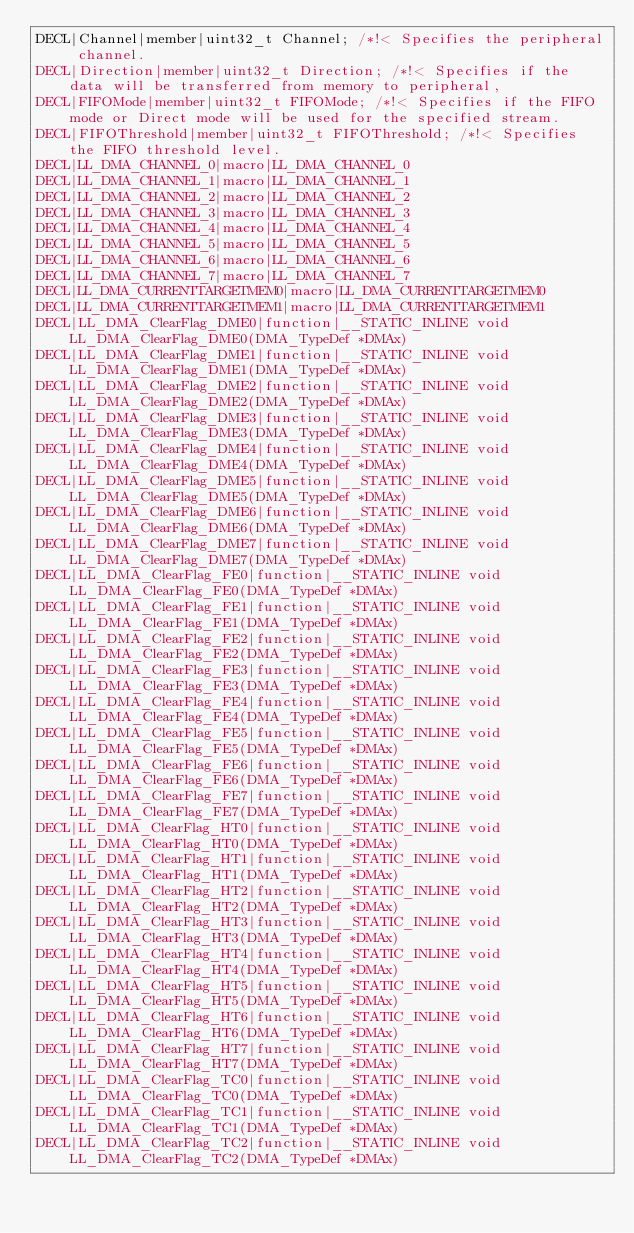<code> <loc_0><loc_0><loc_500><loc_500><_C_>DECL|Channel|member|uint32_t Channel; /*!< Specifies the peripheral channel.
DECL|Direction|member|uint32_t Direction; /*!< Specifies if the data will be transferred from memory to peripheral,
DECL|FIFOMode|member|uint32_t FIFOMode; /*!< Specifies if the FIFO mode or Direct mode will be used for the specified stream.
DECL|FIFOThreshold|member|uint32_t FIFOThreshold; /*!< Specifies the FIFO threshold level.
DECL|LL_DMA_CHANNEL_0|macro|LL_DMA_CHANNEL_0
DECL|LL_DMA_CHANNEL_1|macro|LL_DMA_CHANNEL_1
DECL|LL_DMA_CHANNEL_2|macro|LL_DMA_CHANNEL_2
DECL|LL_DMA_CHANNEL_3|macro|LL_DMA_CHANNEL_3
DECL|LL_DMA_CHANNEL_4|macro|LL_DMA_CHANNEL_4
DECL|LL_DMA_CHANNEL_5|macro|LL_DMA_CHANNEL_5
DECL|LL_DMA_CHANNEL_6|macro|LL_DMA_CHANNEL_6
DECL|LL_DMA_CHANNEL_7|macro|LL_DMA_CHANNEL_7
DECL|LL_DMA_CURRENTTARGETMEM0|macro|LL_DMA_CURRENTTARGETMEM0
DECL|LL_DMA_CURRENTTARGETMEM1|macro|LL_DMA_CURRENTTARGETMEM1
DECL|LL_DMA_ClearFlag_DME0|function|__STATIC_INLINE void LL_DMA_ClearFlag_DME0(DMA_TypeDef *DMAx)
DECL|LL_DMA_ClearFlag_DME1|function|__STATIC_INLINE void LL_DMA_ClearFlag_DME1(DMA_TypeDef *DMAx)
DECL|LL_DMA_ClearFlag_DME2|function|__STATIC_INLINE void LL_DMA_ClearFlag_DME2(DMA_TypeDef *DMAx)
DECL|LL_DMA_ClearFlag_DME3|function|__STATIC_INLINE void LL_DMA_ClearFlag_DME3(DMA_TypeDef *DMAx)
DECL|LL_DMA_ClearFlag_DME4|function|__STATIC_INLINE void LL_DMA_ClearFlag_DME4(DMA_TypeDef *DMAx)
DECL|LL_DMA_ClearFlag_DME5|function|__STATIC_INLINE void LL_DMA_ClearFlag_DME5(DMA_TypeDef *DMAx)
DECL|LL_DMA_ClearFlag_DME6|function|__STATIC_INLINE void LL_DMA_ClearFlag_DME6(DMA_TypeDef *DMAx)
DECL|LL_DMA_ClearFlag_DME7|function|__STATIC_INLINE void LL_DMA_ClearFlag_DME7(DMA_TypeDef *DMAx)
DECL|LL_DMA_ClearFlag_FE0|function|__STATIC_INLINE void LL_DMA_ClearFlag_FE0(DMA_TypeDef *DMAx)
DECL|LL_DMA_ClearFlag_FE1|function|__STATIC_INLINE void LL_DMA_ClearFlag_FE1(DMA_TypeDef *DMAx)
DECL|LL_DMA_ClearFlag_FE2|function|__STATIC_INLINE void LL_DMA_ClearFlag_FE2(DMA_TypeDef *DMAx)
DECL|LL_DMA_ClearFlag_FE3|function|__STATIC_INLINE void LL_DMA_ClearFlag_FE3(DMA_TypeDef *DMAx)
DECL|LL_DMA_ClearFlag_FE4|function|__STATIC_INLINE void LL_DMA_ClearFlag_FE4(DMA_TypeDef *DMAx)
DECL|LL_DMA_ClearFlag_FE5|function|__STATIC_INLINE void LL_DMA_ClearFlag_FE5(DMA_TypeDef *DMAx)
DECL|LL_DMA_ClearFlag_FE6|function|__STATIC_INLINE void LL_DMA_ClearFlag_FE6(DMA_TypeDef *DMAx)
DECL|LL_DMA_ClearFlag_FE7|function|__STATIC_INLINE void LL_DMA_ClearFlag_FE7(DMA_TypeDef *DMAx)
DECL|LL_DMA_ClearFlag_HT0|function|__STATIC_INLINE void LL_DMA_ClearFlag_HT0(DMA_TypeDef *DMAx)
DECL|LL_DMA_ClearFlag_HT1|function|__STATIC_INLINE void LL_DMA_ClearFlag_HT1(DMA_TypeDef *DMAx)
DECL|LL_DMA_ClearFlag_HT2|function|__STATIC_INLINE void LL_DMA_ClearFlag_HT2(DMA_TypeDef *DMAx)
DECL|LL_DMA_ClearFlag_HT3|function|__STATIC_INLINE void LL_DMA_ClearFlag_HT3(DMA_TypeDef *DMAx)
DECL|LL_DMA_ClearFlag_HT4|function|__STATIC_INLINE void LL_DMA_ClearFlag_HT4(DMA_TypeDef *DMAx)
DECL|LL_DMA_ClearFlag_HT5|function|__STATIC_INLINE void LL_DMA_ClearFlag_HT5(DMA_TypeDef *DMAx)
DECL|LL_DMA_ClearFlag_HT6|function|__STATIC_INLINE void LL_DMA_ClearFlag_HT6(DMA_TypeDef *DMAx)
DECL|LL_DMA_ClearFlag_HT7|function|__STATIC_INLINE void LL_DMA_ClearFlag_HT7(DMA_TypeDef *DMAx)
DECL|LL_DMA_ClearFlag_TC0|function|__STATIC_INLINE void LL_DMA_ClearFlag_TC0(DMA_TypeDef *DMAx)
DECL|LL_DMA_ClearFlag_TC1|function|__STATIC_INLINE void LL_DMA_ClearFlag_TC1(DMA_TypeDef *DMAx)
DECL|LL_DMA_ClearFlag_TC2|function|__STATIC_INLINE void LL_DMA_ClearFlag_TC2(DMA_TypeDef *DMAx)</code> 